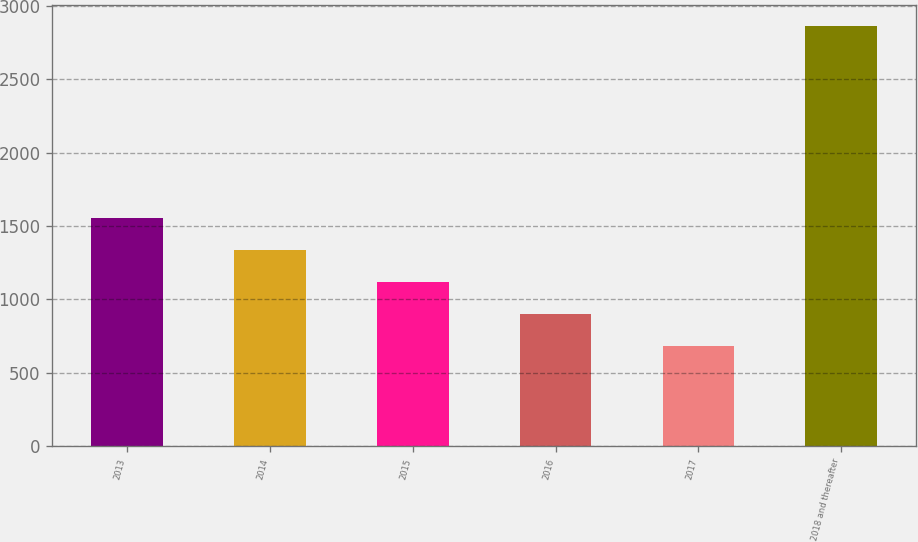Convert chart. <chart><loc_0><loc_0><loc_500><loc_500><bar_chart><fcel>2013<fcel>2014<fcel>2015<fcel>2016<fcel>2017<fcel>2018 and thereafter<nl><fcel>1553.44<fcel>1334.83<fcel>1116.22<fcel>897.61<fcel>679<fcel>2865.1<nl></chart> 